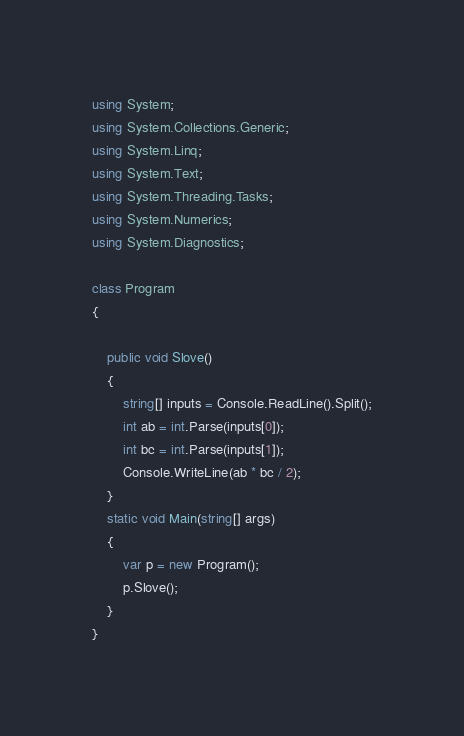<code> <loc_0><loc_0><loc_500><loc_500><_C#_>using System;
using System.Collections.Generic;
using System.Linq;
using System.Text;
using System.Threading.Tasks;
using System.Numerics;
using System.Diagnostics;

class Program
{

    public void Slove()
    {
        string[] inputs = Console.ReadLine().Split();
        int ab = int.Parse(inputs[0]);
        int bc = int.Parse(inputs[1]);
        Console.WriteLine(ab * bc / 2);
    }
    static void Main(string[] args)
    {
        var p = new Program();
        p.Slove();
    }
}
</code> 